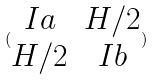<formula> <loc_0><loc_0><loc_500><loc_500>( \begin{matrix} I a & H / 2 \\ H / 2 & I b \end{matrix} )</formula> 